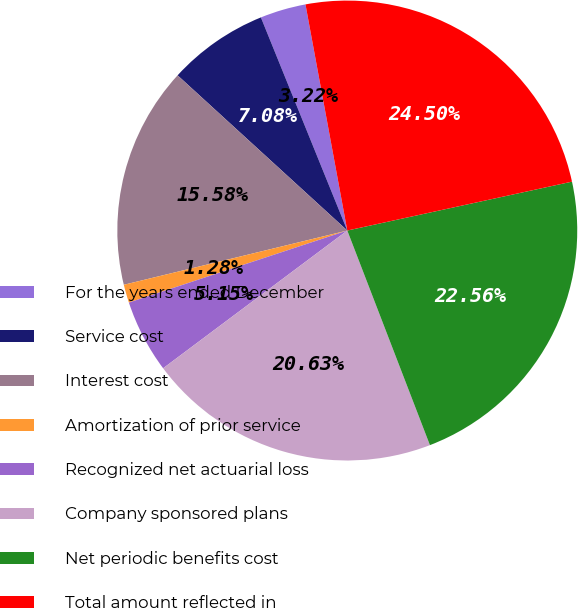<chart> <loc_0><loc_0><loc_500><loc_500><pie_chart><fcel>For the years ended December<fcel>Service cost<fcel>Interest cost<fcel>Amortization of prior service<fcel>Recognized net actuarial loss<fcel>Company sponsored plans<fcel>Net periodic benefits cost<fcel>Total amount reflected in<nl><fcel>3.22%<fcel>7.08%<fcel>15.58%<fcel>1.28%<fcel>5.15%<fcel>20.63%<fcel>22.56%<fcel>24.5%<nl></chart> 